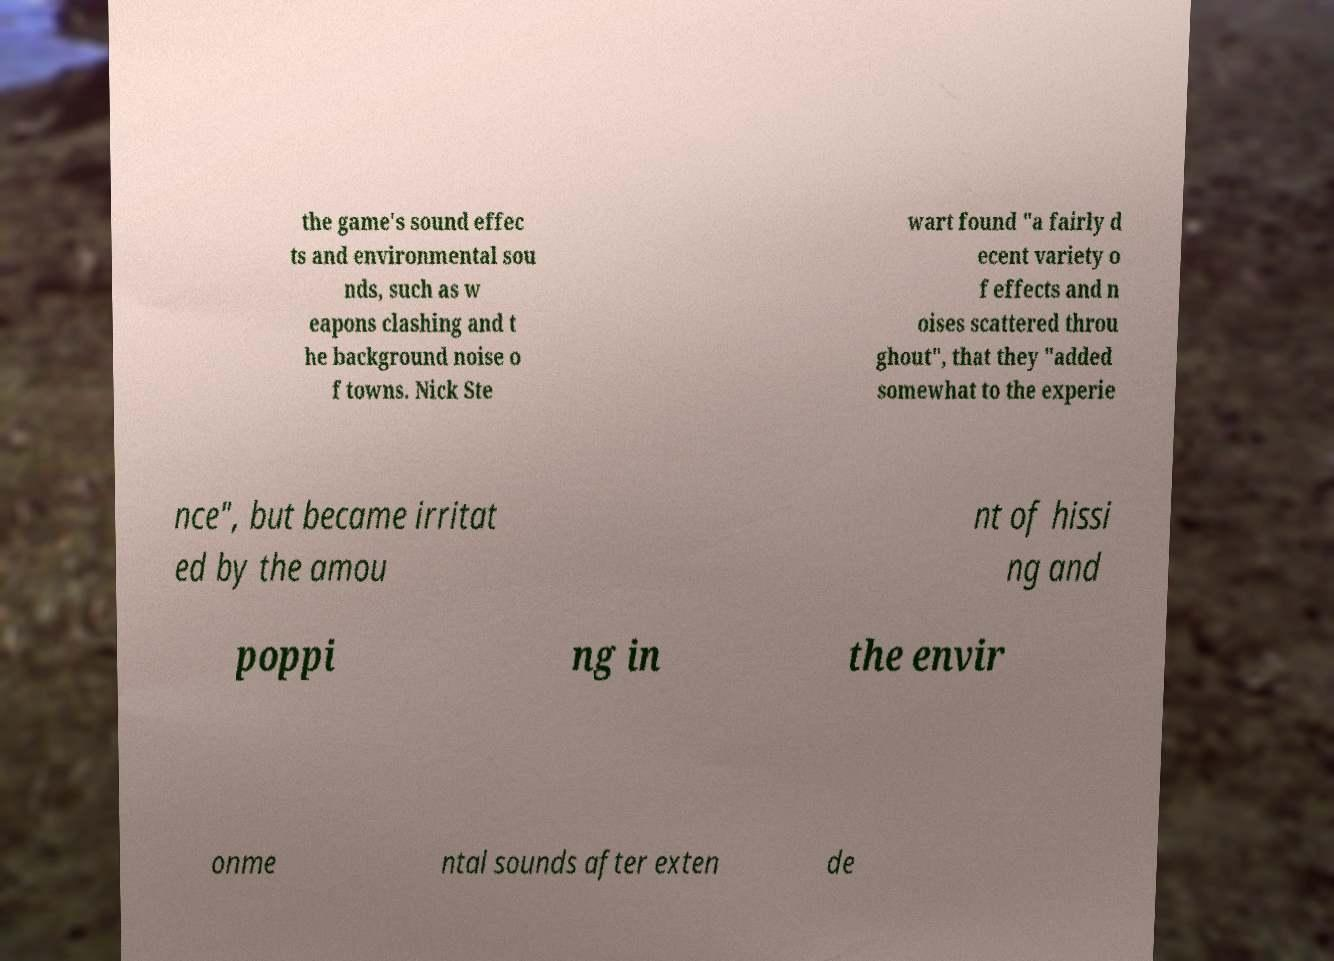Can you accurately transcribe the text from the provided image for me? the game's sound effec ts and environmental sou nds, such as w eapons clashing and t he background noise o f towns. Nick Ste wart found "a fairly d ecent variety o f effects and n oises scattered throu ghout", that they "added somewhat to the experie nce", but became irritat ed by the amou nt of hissi ng and poppi ng in the envir onme ntal sounds after exten de 